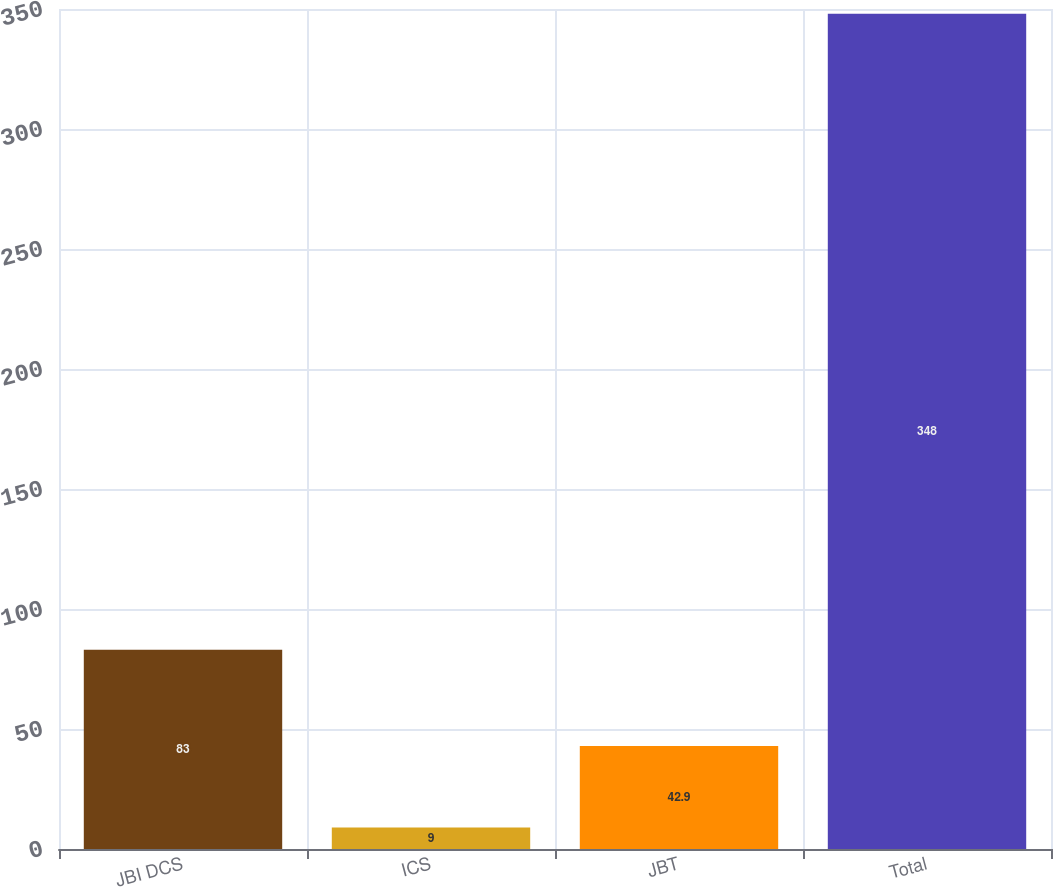<chart> <loc_0><loc_0><loc_500><loc_500><bar_chart><fcel>JBI DCS<fcel>ICS<fcel>JBT<fcel>Total<nl><fcel>83<fcel>9<fcel>42.9<fcel>348<nl></chart> 